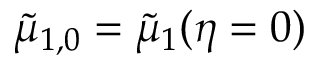<formula> <loc_0><loc_0><loc_500><loc_500>\tilde { \mu } _ { 1 , 0 } = \tilde { \mu } _ { 1 } ( \eta = 0 )</formula> 